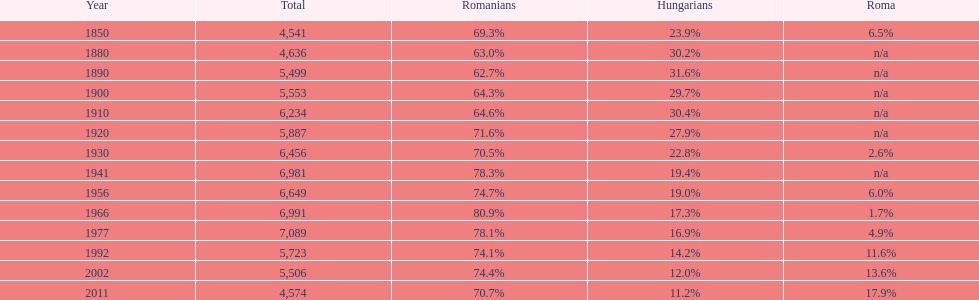Which year is prior to the year with 7 1977. 